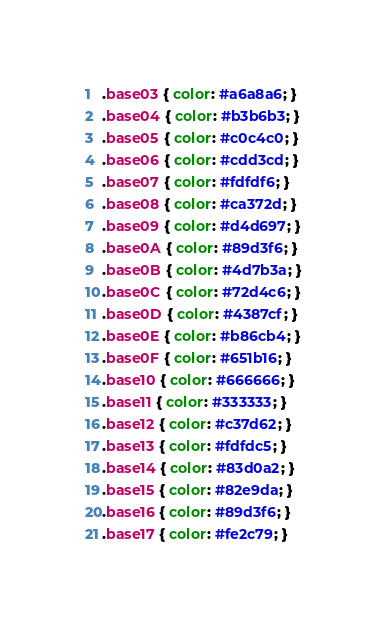<code> <loc_0><loc_0><loc_500><loc_500><_CSS_>.base03 { color: #a6a8a6; }
.base04 { color: #b3b6b3; }
.base05 { color: #c0c4c0; }
.base06 { color: #cdd3cd; }
.base07 { color: #fdfdf6; }
.base08 { color: #ca372d; }
.base09 { color: #d4d697; }
.base0A { color: #89d3f6; }
.base0B { color: #4d7b3a; }
.base0C { color: #72d4c6; }
.base0D { color: #4387cf; }
.base0E { color: #b86cb4; }
.base0F { color: #651b16; }
.base10 { color: #666666; }
.base11 { color: #333333; }
.base12 { color: #c37d62; }
.base13 { color: #fdfdc5; }
.base14 { color: #83d0a2; }
.base15 { color: #82e9da; }
.base16 { color: #89d3f6; }
.base17 { color: #fe2c79; }
</code> 